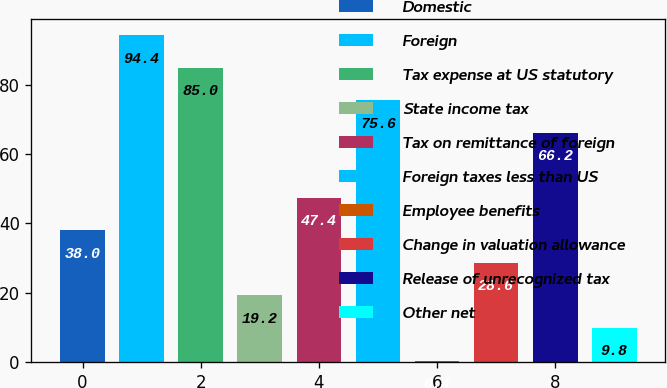<chart> <loc_0><loc_0><loc_500><loc_500><bar_chart><fcel>Domestic<fcel>Foreign<fcel>Tax expense at US statutory<fcel>State income tax<fcel>Tax on remittance of foreign<fcel>Foreign taxes less than US<fcel>Employee benefits<fcel>Change in valuation allowance<fcel>Release of unrecognized tax<fcel>Other net<nl><fcel>38<fcel>94.4<fcel>85<fcel>19.2<fcel>47.4<fcel>75.6<fcel>0.4<fcel>28.6<fcel>66.2<fcel>9.8<nl></chart> 